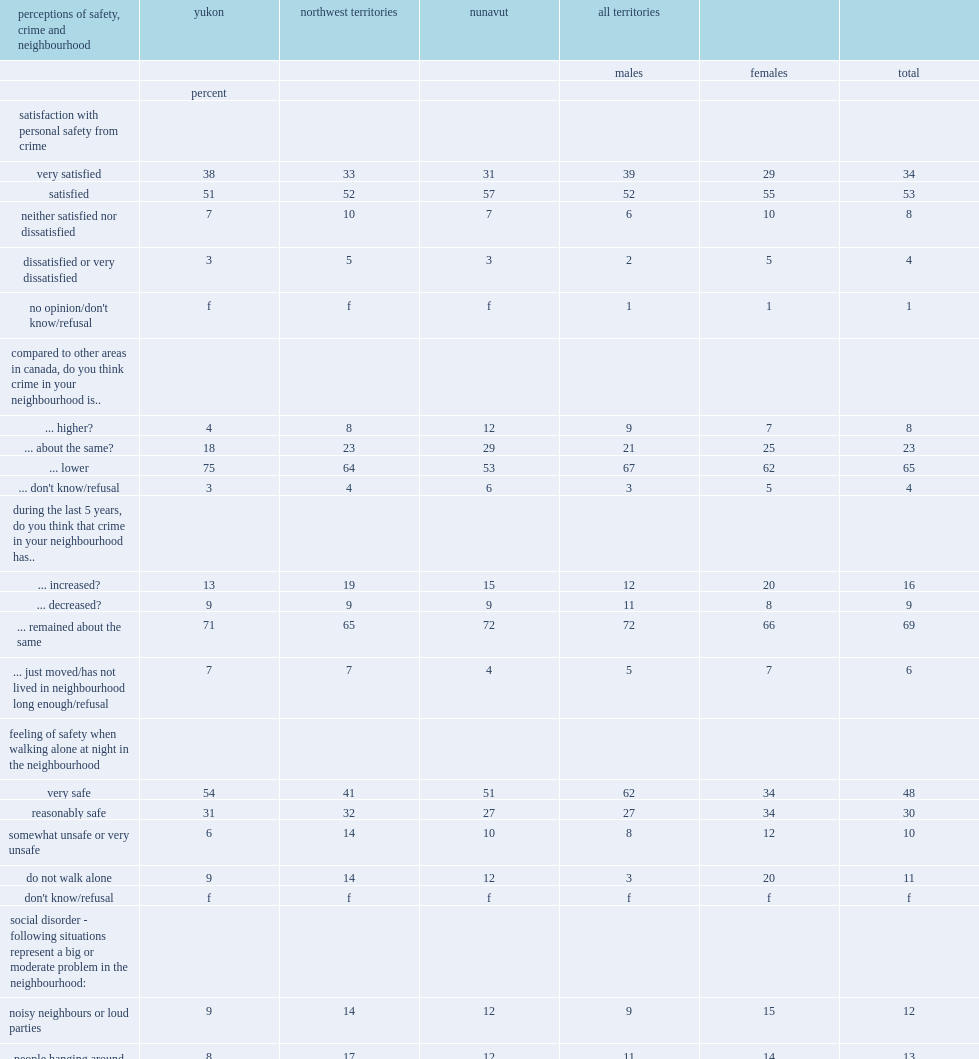What percentage of residents say that they are very satisfied or satisfied with their personal safety? 87. 38% of yukon residents would report being very satisfied with their personal safety from crime. 38.0. 31% of nunavut residents would report being very satisfied with their personal safety from crime. 31.0. What percentage of yukon residents believe that their community's crime rate is lower than that of the rest of canada? 75.0. What percentage of nunavut residents believe that their community's crime rate is lower than that of the rest of canada? 53.0. What percentage of residents report that at least one kind of social disorder is a major or medium-sized problem in their community? 41.0. What percentage of nunavut residents would report at least one sign of social disorder? 50.0. What percentage of yukon residents would report at least one sign of social disorder? 28.0. What is the percentage of people being drunk or rowdy in public places? 26.0. What is the percentage of people dealing or using drugs? 22.0. What is the percentage of garbage or litter lying around? 16.0. What is the percentage of vandalism, graffiti and other deliberate damage to property or vehicles? 15.0. 